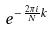<formula> <loc_0><loc_0><loc_500><loc_500>e ^ { - \frac { 2 \pi i } { N } k }</formula> 